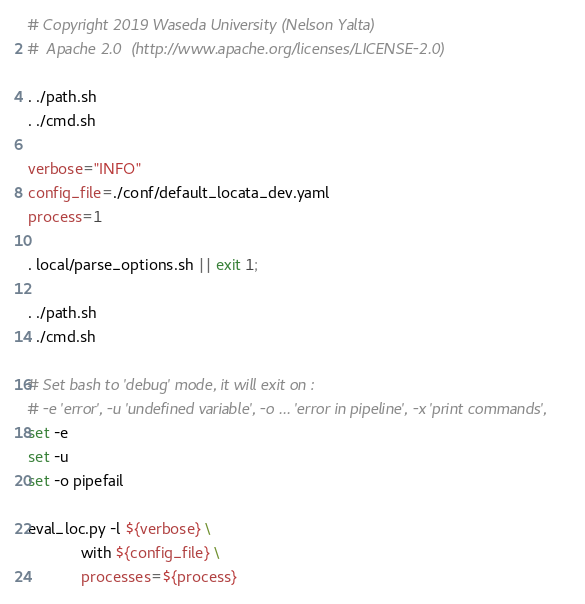Convert code to text. <code><loc_0><loc_0><loc_500><loc_500><_Bash_># Copyright 2019 Waseda University (Nelson Yalta)
#  Apache 2.0  (http://www.apache.org/licenses/LICENSE-2.0)

. ./path.sh
. ./cmd.sh

verbose="INFO"
config_file=./conf/default_locata_dev.yaml
process=1

. local/parse_options.sh || exit 1;

. ./path.sh
. ./cmd.sh

# Set bash to 'debug' mode, it will exit on :
# -e 'error', -u 'undefined variable', -o ... 'error in pipeline', -x 'print commands',
set -e
set -u
set -o pipefail

eval_loc.py -l ${verbose} \
            with ${config_file} \
            processes=${process}</code> 